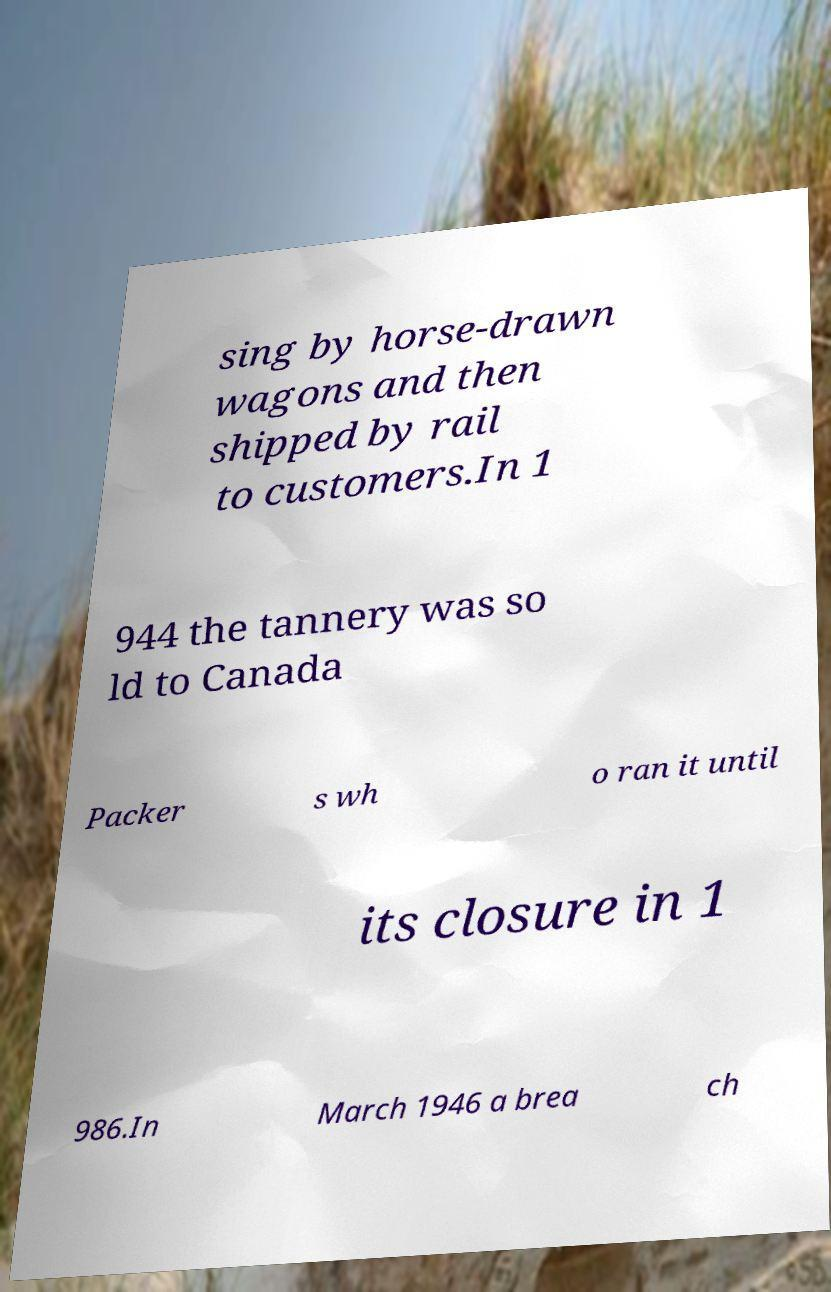Could you extract and type out the text from this image? sing by horse-drawn wagons and then shipped by rail to customers.In 1 944 the tannery was so ld to Canada Packer s wh o ran it until its closure in 1 986.In March 1946 a brea ch 